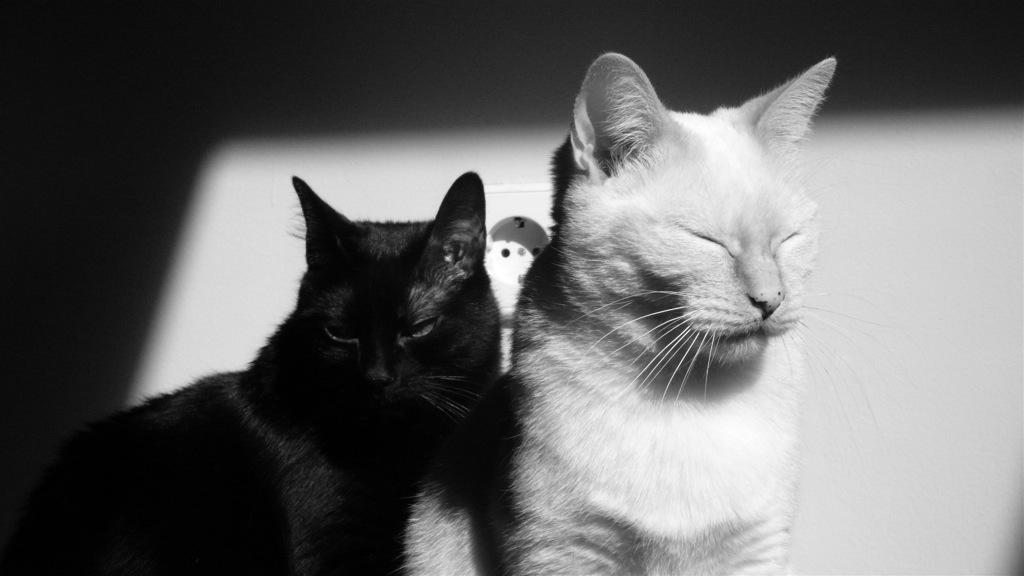What animals are in the foreground of the image? There are two cats in the foreground of the image. What can be seen in the background of the image? There is a wall in the background of the image. What type of furniture is being used by the cats in the image? There is no furniture present in the image; it only features two cats and a wall in the background. 